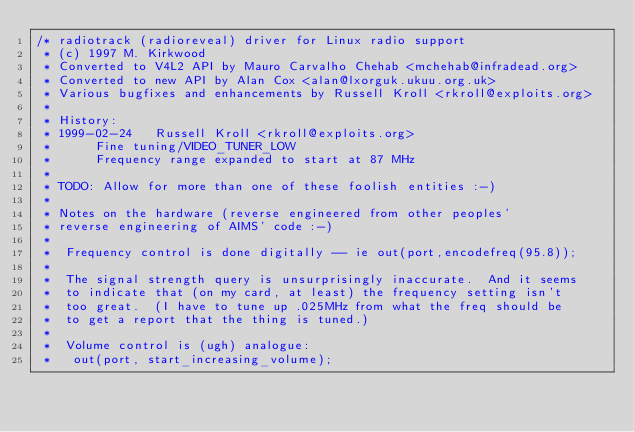Convert code to text. <code><loc_0><loc_0><loc_500><loc_500><_C_>/* radiotrack (radioreveal) driver for Linux radio support
 * (c) 1997 M. Kirkwood
 * Converted to V4L2 API by Mauro Carvalho Chehab <mchehab@infradead.org>
 * Converted to new API by Alan Cox <alan@lxorguk.ukuu.org.uk>
 * Various bugfixes and enhancements by Russell Kroll <rkroll@exploits.org>
 *
 * History:
 * 1999-02-24	Russell Kroll <rkroll@exploits.org>
 * 		Fine tuning/VIDEO_TUNER_LOW
 *		Frequency range expanded to start at 87 MHz
 *
 * TODO: Allow for more than one of these foolish entities :-)
 *
 * Notes on the hardware (reverse engineered from other peoples'
 * reverse engineering of AIMS' code :-)
 *
 *  Frequency control is done digitally -- ie out(port,encodefreq(95.8));
 *
 *  The signal strength query is unsurprisingly inaccurate.  And it seems
 *  to indicate that (on my card, at least) the frequency setting isn't
 *  too great.  (I have to tune up .025MHz from what the freq should be
 *  to get a report that the thing is tuned.)
 *
 *  Volume control is (ugh) analogue:
 *   out(port, start_increasing_volume);</code> 